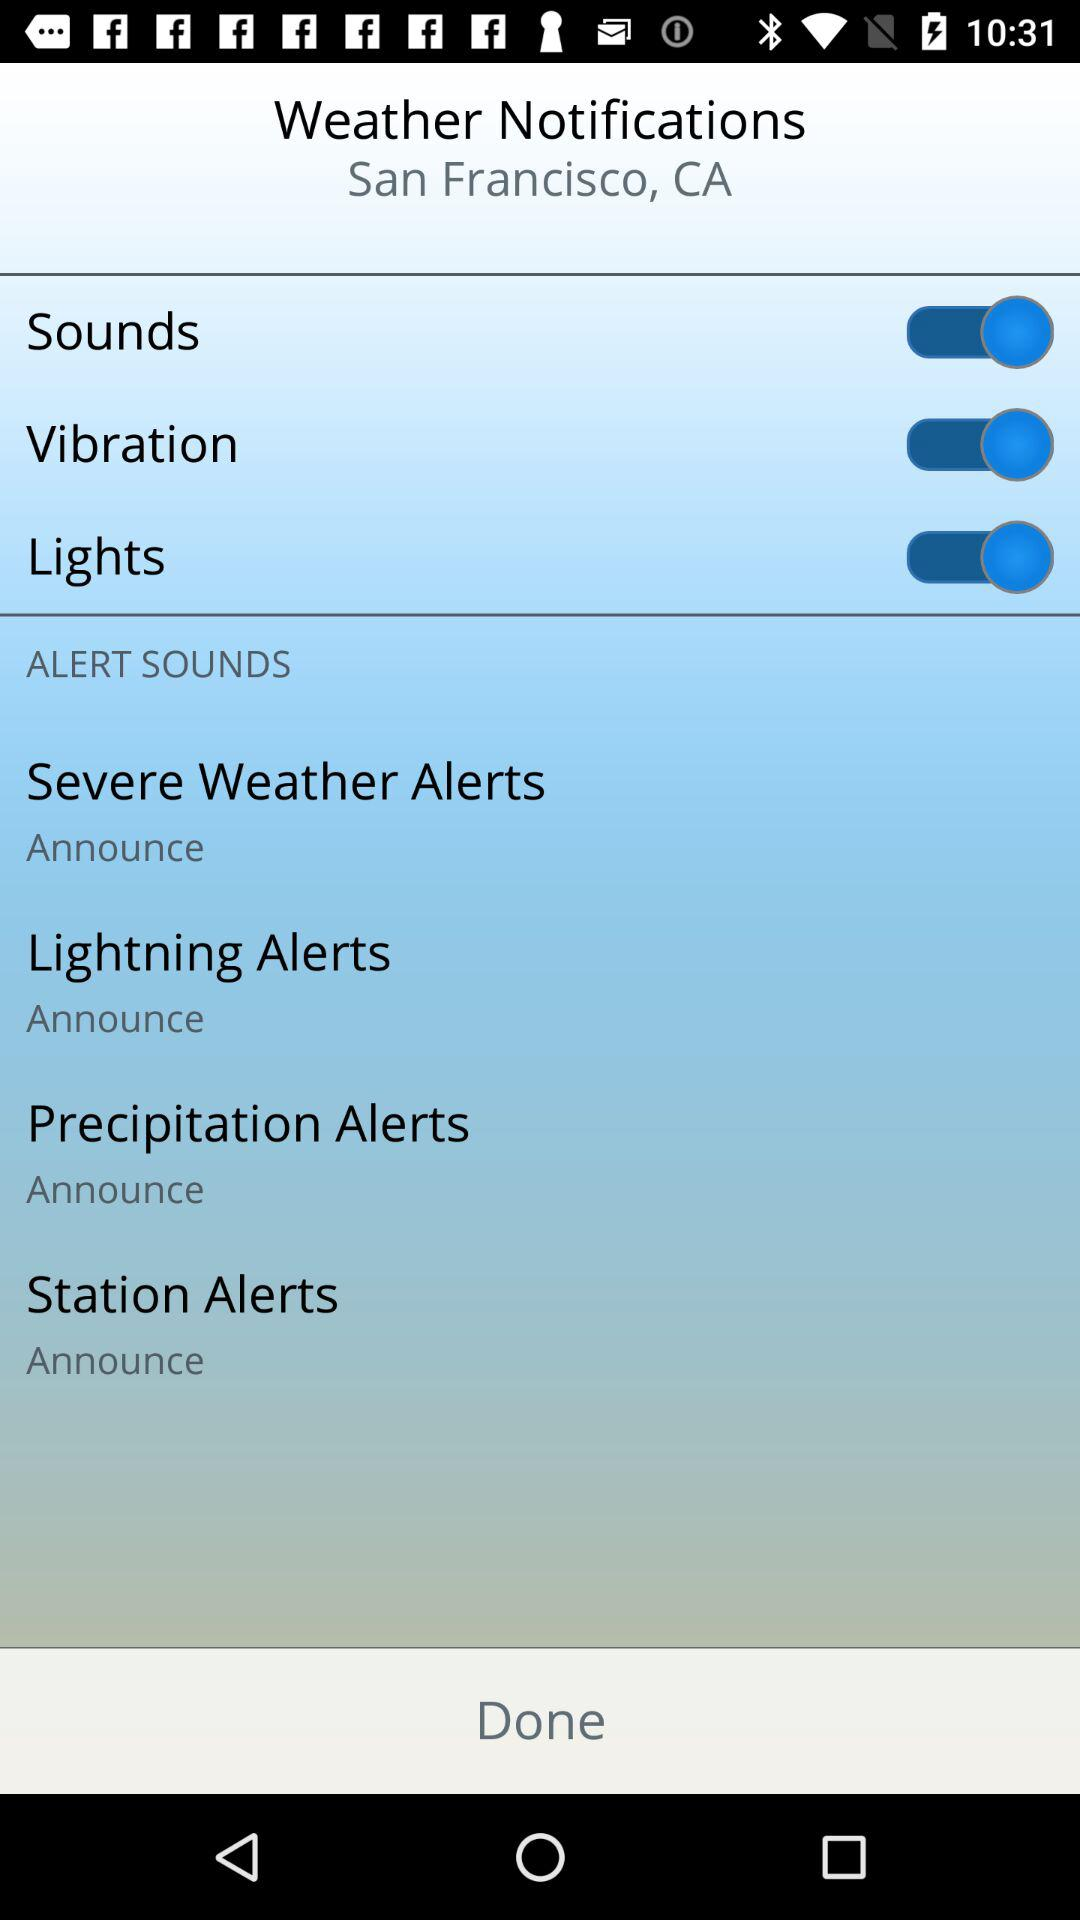How many alerts have an announce option?
Answer the question using a single word or phrase. 4 